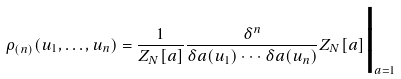Convert formula to latex. <formula><loc_0><loc_0><loc_500><loc_500>\rho _ { ( n ) } ( u _ { 1 } , \dots , u _ { n } ) = \frac { 1 } { Z _ { N } [ a ] } \frac { \delta ^ { n } } { \delta a ( u _ { 1 } ) \cdot \cdot \cdot \delta a ( u _ { n } ) } Z _ { N } [ a ] { \Big | } _ { a = 1 }</formula> 